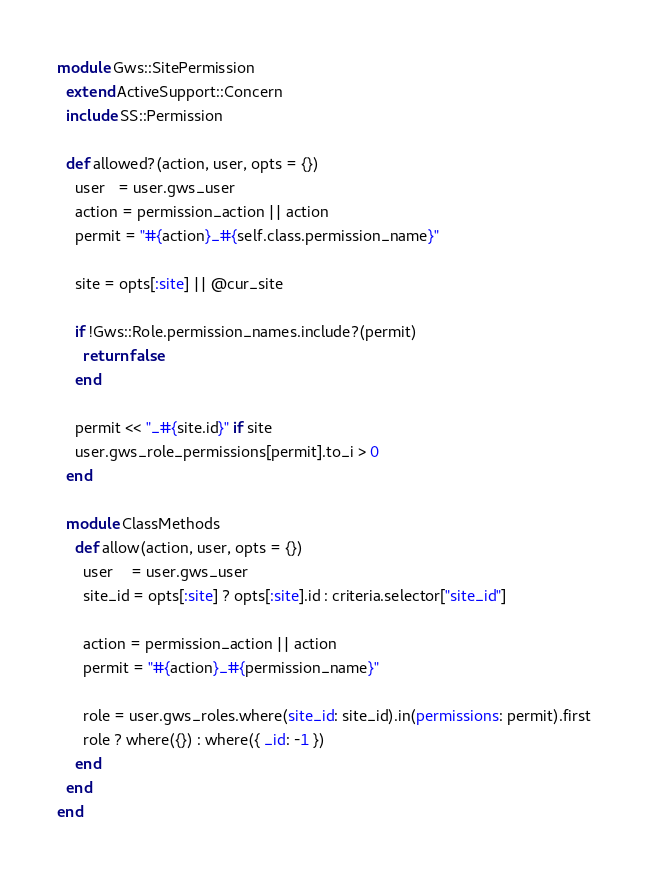Convert code to text. <code><loc_0><loc_0><loc_500><loc_500><_Ruby_>module Gws::SitePermission
  extend ActiveSupport::Concern
  include SS::Permission

  def allowed?(action, user, opts = {})
    user   = user.gws_user
    action = permission_action || action
    permit = "#{action}_#{self.class.permission_name}"

    site = opts[:site] || @cur_site

    if !Gws::Role.permission_names.include?(permit)
      return false
    end

    permit << "_#{site.id}" if site
    user.gws_role_permissions[permit].to_i > 0
  end

  module ClassMethods
    def allow(action, user, opts = {})
      user    = user.gws_user
      site_id = opts[:site] ? opts[:site].id : criteria.selector["site_id"]

      action = permission_action || action
      permit = "#{action}_#{permission_name}"

      role = user.gws_roles.where(site_id: site_id).in(permissions: permit).first
      role ? where({}) : where({ _id: -1 })
    end
  end
end
</code> 